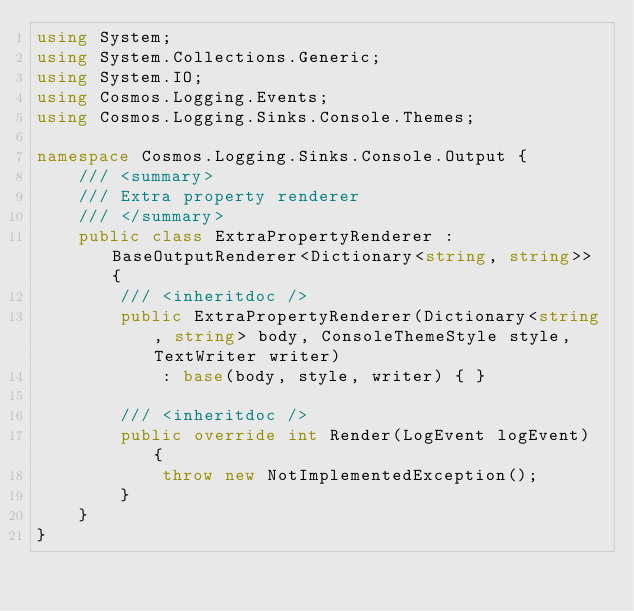Convert code to text. <code><loc_0><loc_0><loc_500><loc_500><_C#_>using System;
using System.Collections.Generic;
using System.IO;
using Cosmos.Logging.Events;
using Cosmos.Logging.Sinks.Console.Themes;

namespace Cosmos.Logging.Sinks.Console.Output {
    /// <summary>
    /// Extra property renderer
    /// </summary>
    public class ExtraPropertyRenderer : BaseOutputRenderer<Dictionary<string, string>> {
        /// <inheritdoc />
        public ExtraPropertyRenderer(Dictionary<string, string> body, ConsoleThemeStyle style, TextWriter writer)
            : base(body, style, writer) { }

        /// <inheritdoc />
        public override int Render(LogEvent logEvent) {
            throw new NotImplementedException();
        }
    }
}</code> 